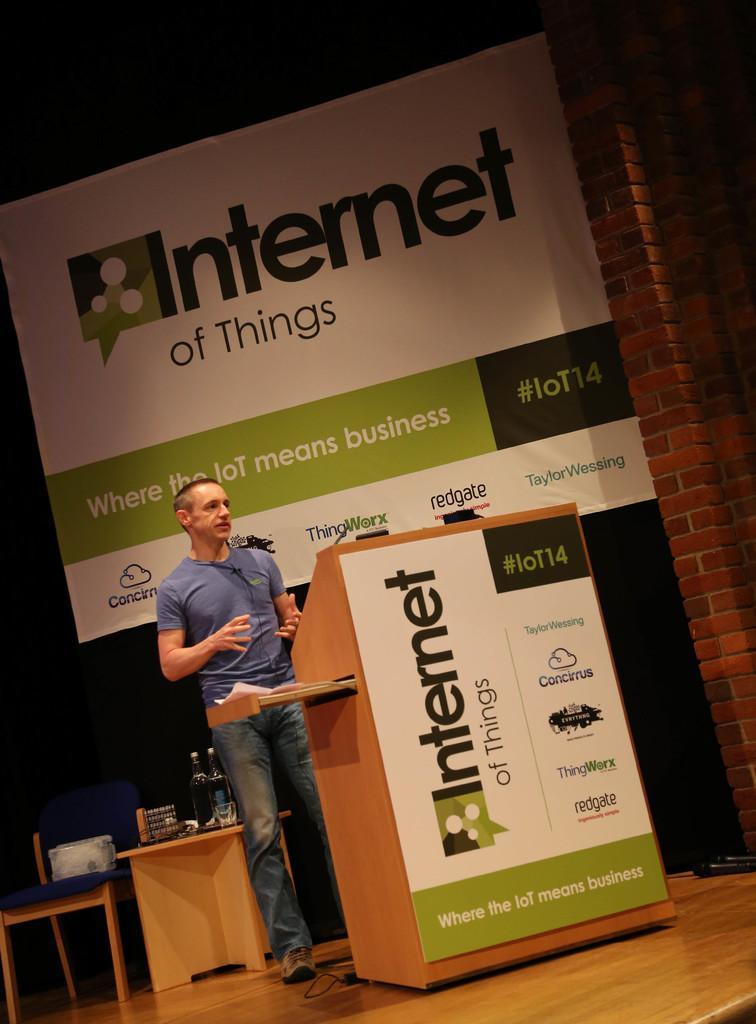In one or two sentences, can you explain what this image depicts? in the picture there is a person standing near the podium near to him there was a table on the table there are different items 